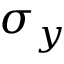Convert formula to latex. <formula><loc_0><loc_0><loc_500><loc_500>\sigma _ { y }</formula> 